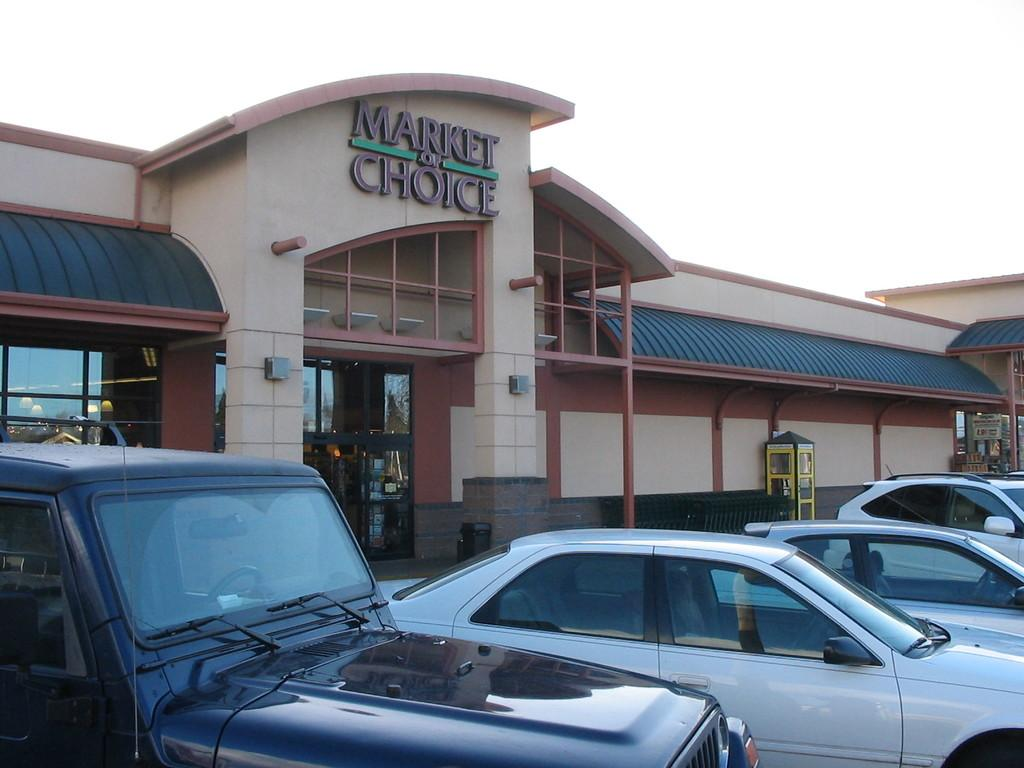What is in the center of the image? There are cars on the road in the center of the image. What can be seen in the background of the image? Buildings, a telephone booth, windows, a door, pillars, and the sky are visible in the background of the image. How many rabbits can be seen hopping on the roof of the car in the image? There are no rabbits present in the image, so it is not possible to determine how many might be hopping on the roof of a car. 